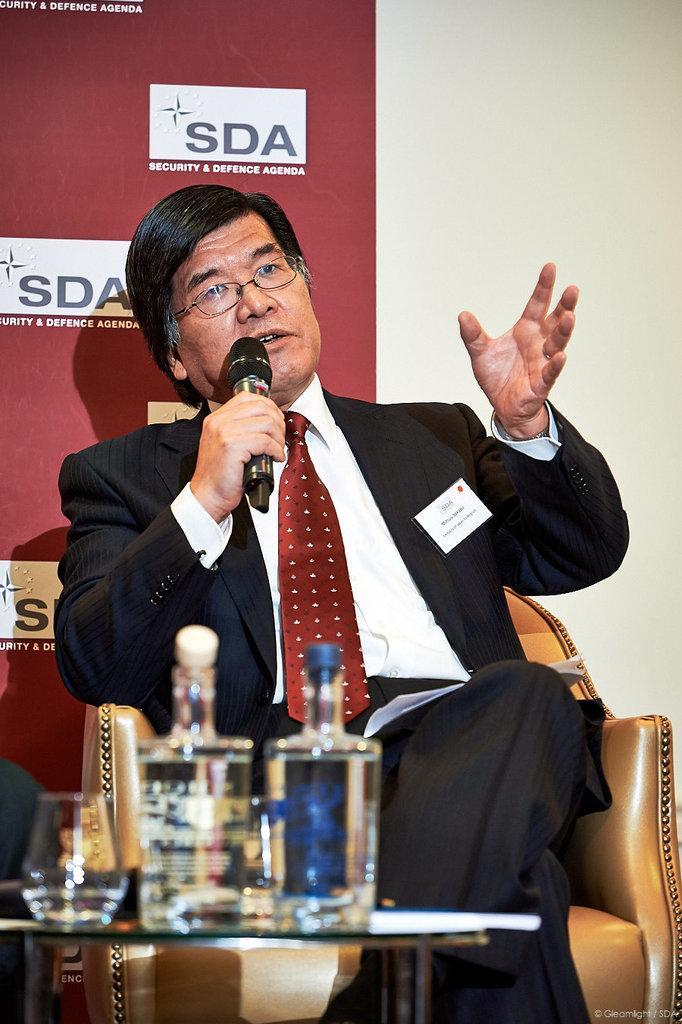Please provide a concise description of this image. In this picture, we see man in white shirt and black blazer is holding microphone in his hands and he is talking on it. In front of him, we see a table on which glass bottle and glass are placed. Behind the man, we see a wall which is white in color and a board in maroon color with some text written on it. 